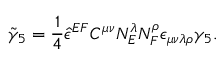Convert formula to latex. <formula><loc_0><loc_0><loc_500><loc_500>{ \tilde { \gamma } _ { 5 } } = \frac { 1 } { 4 } { \hat { \epsilon } } ^ { E F } C ^ { \mu \nu } N _ { E } ^ { \lambda } N _ { F } ^ { \rho } \epsilon _ { \mu \nu \lambda \rho } \gamma _ { 5 } .</formula> 